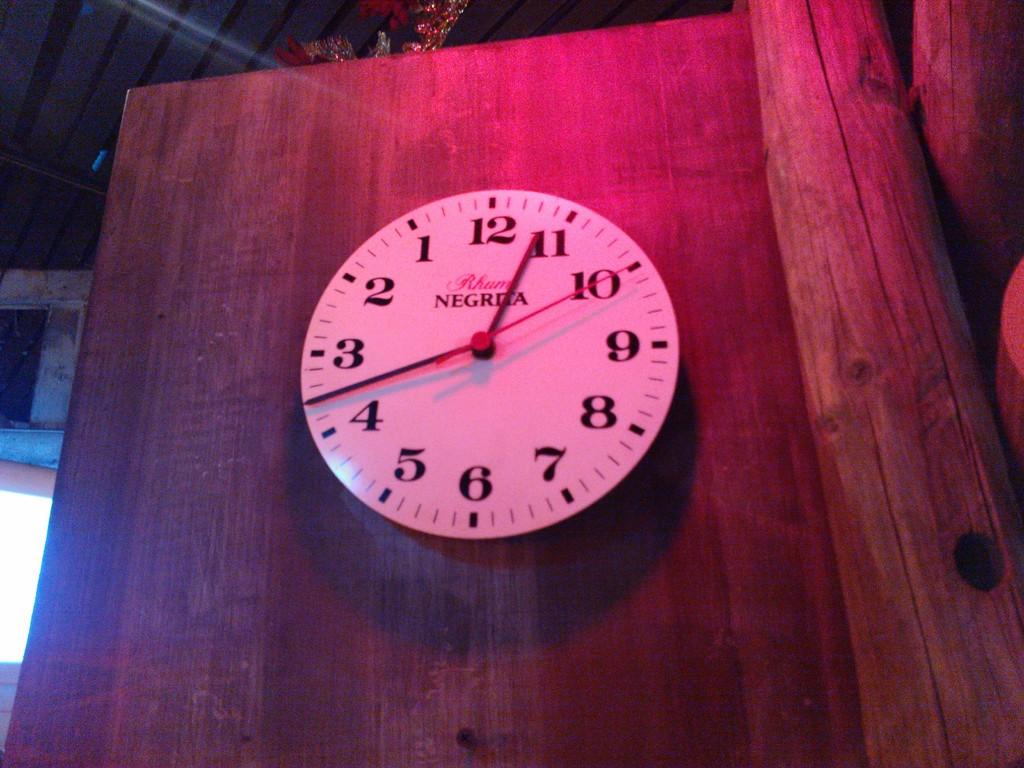What's the time that is read on this clock?
Offer a terse response. 11:18. What´s the brand of the clock?
Offer a terse response. Negria. 